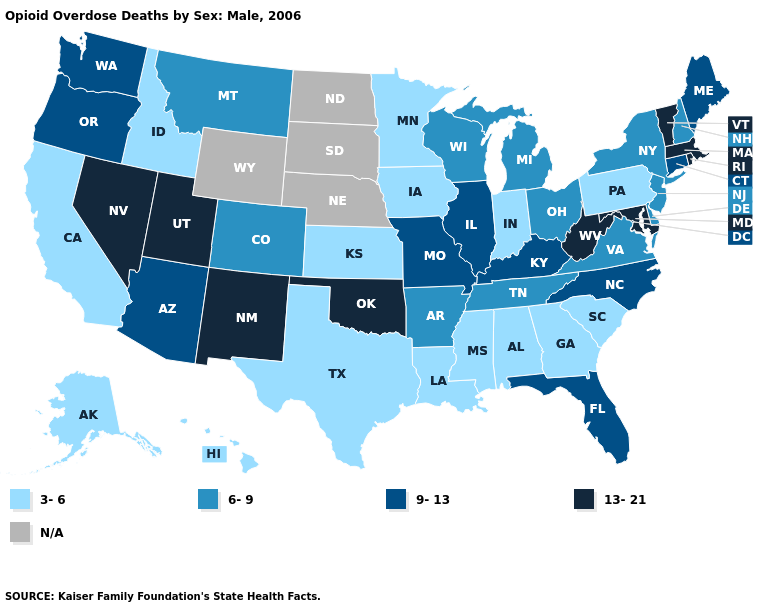What is the highest value in states that border Idaho?
Write a very short answer. 13-21. How many symbols are there in the legend?
Write a very short answer. 5. Name the states that have a value in the range 3-6?
Write a very short answer. Alabama, Alaska, California, Georgia, Hawaii, Idaho, Indiana, Iowa, Kansas, Louisiana, Minnesota, Mississippi, Pennsylvania, South Carolina, Texas. What is the lowest value in states that border Georgia?
Quick response, please. 3-6. Does Massachusetts have the highest value in the USA?
Concise answer only. Yes. Does Connecticut have the highest value in the Northeast?
Concise answer only. No. What is the lowest value in states that border North Dakota?
Write a very short answer. 3-6. Among the states that border Oregon , does Nevada have the highest value?
Keep it brief. Yes. What is the highest value in the USA?
Concise answer only. 13-21. Name the states that have a value in the range 3-6?
Quick response, please. Alabama, Alaska, California, Georgia, Hawaii, Idaho, Indiana, Iowa, Kansas, Louisiana, Minnesota, Mississippi, Pennsylvania, South Carolina, Texas. Name the states that have a value in the range 6-9?
Keep it brief. Arkansas, Colorado, Delaware, Michigan, Montana, New Hampshire, New Jersey, New York, Ohio, Tennessee, Virginia, Wisconsin. 